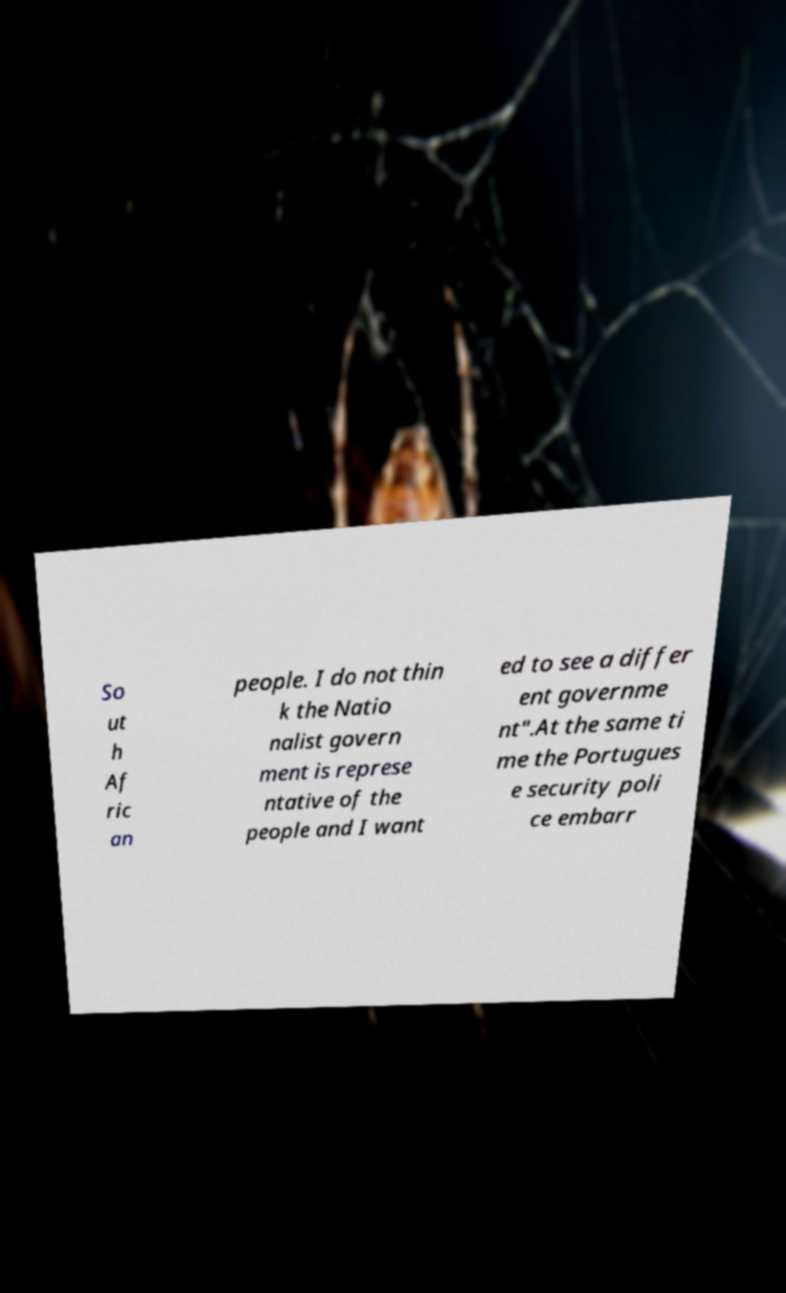There's text embedded in this image that I need extracted. Can you transcribe it verbatim? So ut h Af ric an people. I do not thin k the Natio nalist govern ment is represe ntative of the people and I want ed to see a differ ent governme nt".At the same ti me the Portugues e security poli ce embarr 